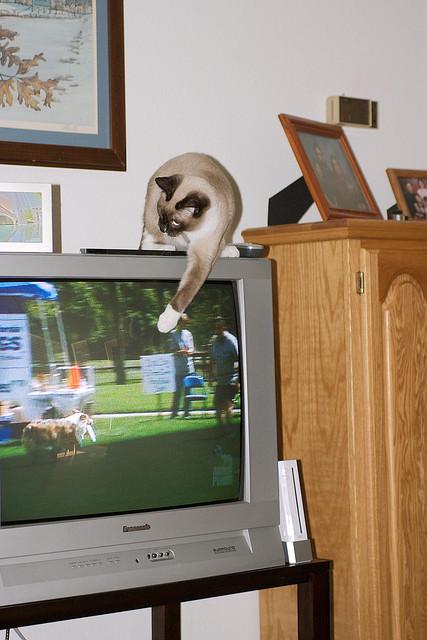What is on top of the TV?
Give a very brief answer. Cat. There is a dog?
Short answer required. No. Is the cat in motion?
Answer briefly. Yes. What kind of cat is there?
Give a very brief answer. Siamese. How many colors is the cat?
Quick response, please. 2. Is the TV turned on?
Answer briefly. Yes. What object is the cat on top of?
Keep it brief. Tv. 